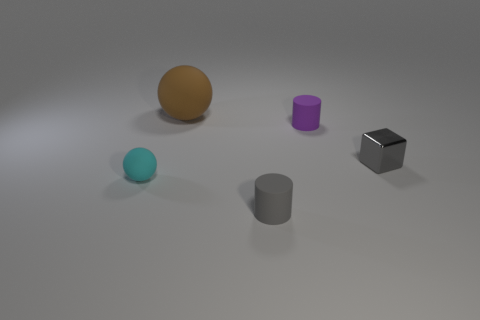Add 5 large brown things. How many objects exist? 10 Subtract all spheres. How many objects are left? 3 Add 2 gray metallic things. How many gray metallic things are left? 3 Add 4 small brown matte things. How many small brown matte things exist? 4 Subtract 0 blue cylinders. How many objects are left? 5 Subtract all brown matte spheres. Subtract all tiny cyan rubber objects. How many objects are left? 3 